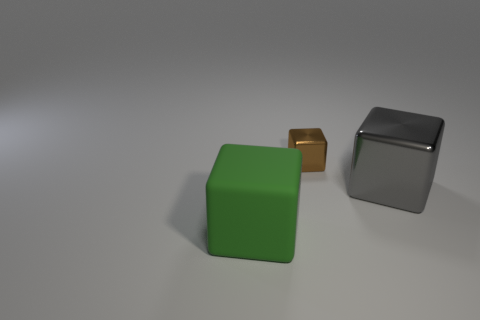Subtract all blue blocks. Subtract all red cylinders. How many blocks are left? 3 Add 1 matte cubes. How many objects exist? 4 Add 2 brown things. How many brown things exist? 3 Subtract 0 purple blocks. How many objects are left? 3 Subtract all rubber cubes. Subtract all tiny brown metal cubes. How many objects are left? 1 Add 1 big matte objects. How many big matte objects are left? 2 